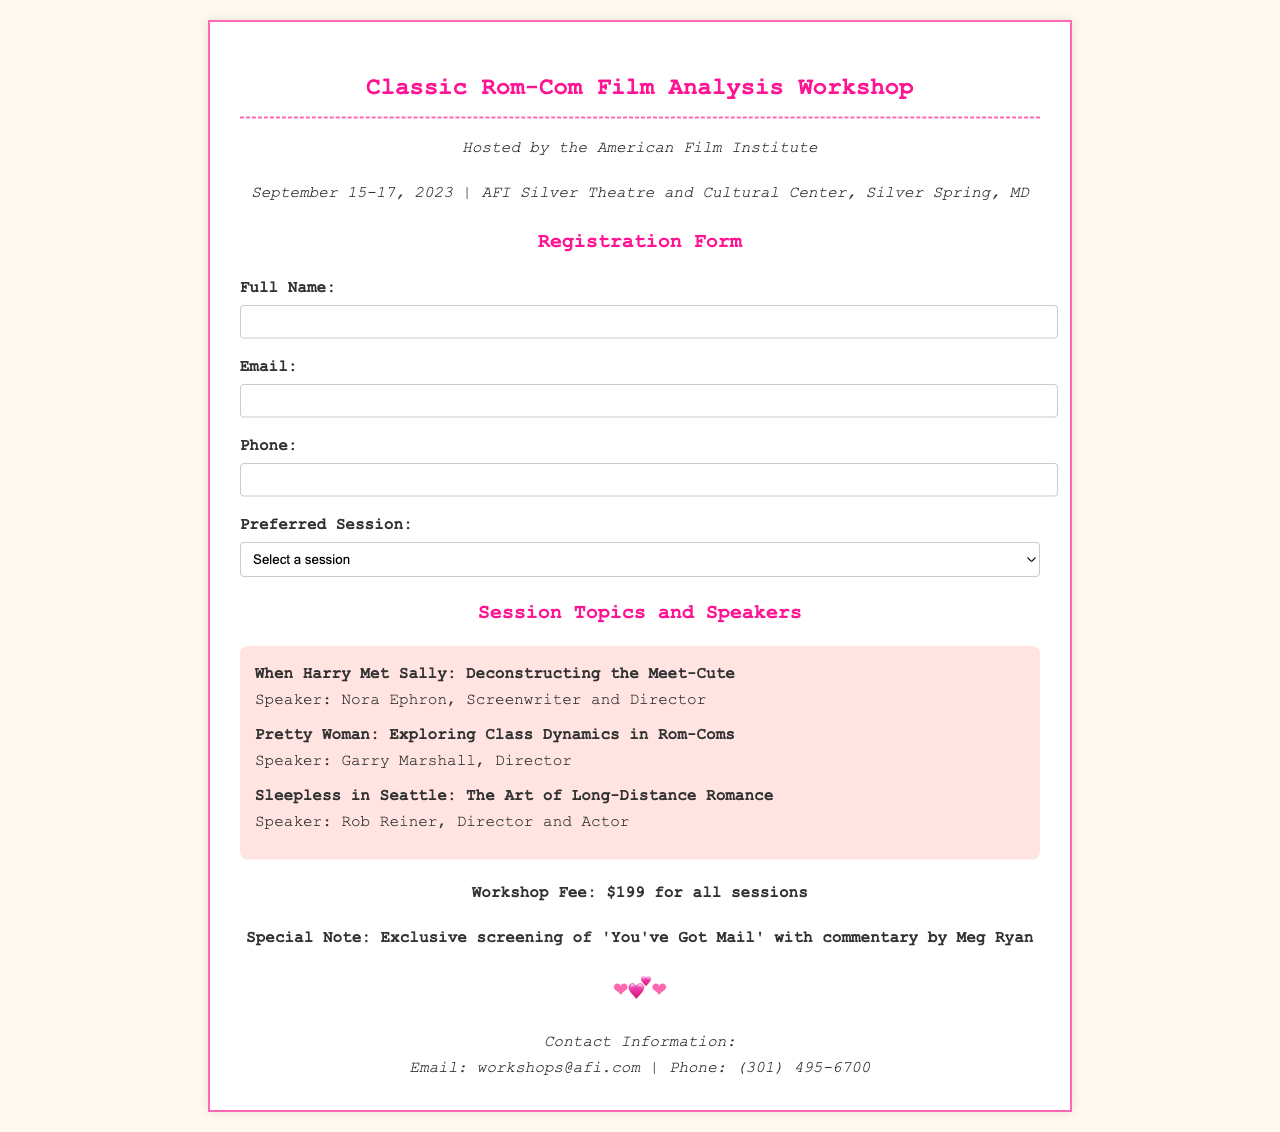What are the dates of the workshop? The dates listed for the workshop in the document are September 15-17, 2023.
Answer: September 15-17, 2023 Who is the speaker for "Sleepless in Seattle"? The document states that Rob Reiner is the speaker for the session titled "Sleepless in Seattle: The Art of Long-Distance Romance."
Answer: Rob Reiner What is the registration fee for the workshop? The workshop fee mentioned in the document is $199 for all sessions.
Answer: $199 What type of film will be screened during the workshop? The document notes that there will be an exclusive screening of 'You've Got Mail' with commentary by Meg Ryan.
Answer: 'You've Got Mail' Which session explores class dynamics in rom-coms? According to the document, the session exploring class dynamics is "Pretty Woman: Exploring Class Dynamics in Rom-Coms."
Answer: Pretty Woman What is the email contact for the workshop? The document provides the email contact for the workshop as workshops@afi.com.
Answer: workshops@afi.com What is the maximum number of attendees likely suggested by the document format? The registration form implies there may be a limited number of spaces, indicated by the requirement sections, but does not specify a number.
Answer: Not specified What is the name of the organization hosting the workshop? The document indicates that the workshop is hosted by the American Film Institute.
Answer: American Film Institute 